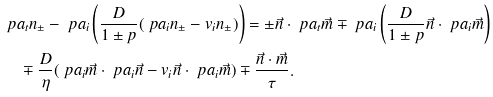Convert formula to latex. <formula><loc_0><loc_0><loc_500><loc_500>& \ p a _ { t } n _ { \pm } - \ p a _ { i } \left ( \frac { D } { 1 \pm p } ( \ p a _ { i } n _ { \pm } - v _ { i } n _ { \pm } ) \right ) = \pm \vec { n } \cdot \ p a _ { t } \vec { m } \mp \ p a _ { i } \left ( \frac { D } { 1 \pm p } \vec { n } \cdot \ p a _ { i } \vec { m } \right ) \\ & \quad \mp \frac { D } { \eta } ( \ p a _ { i } \vec { m } \cdot \ p a _ { i } \vec { n } - v _ { i } \vec { n } \cdot \ p a _ { i } \vec { m } ) \mp \frac { \vec { n } \cdot \vec { m } } { \tau } .</formula> 